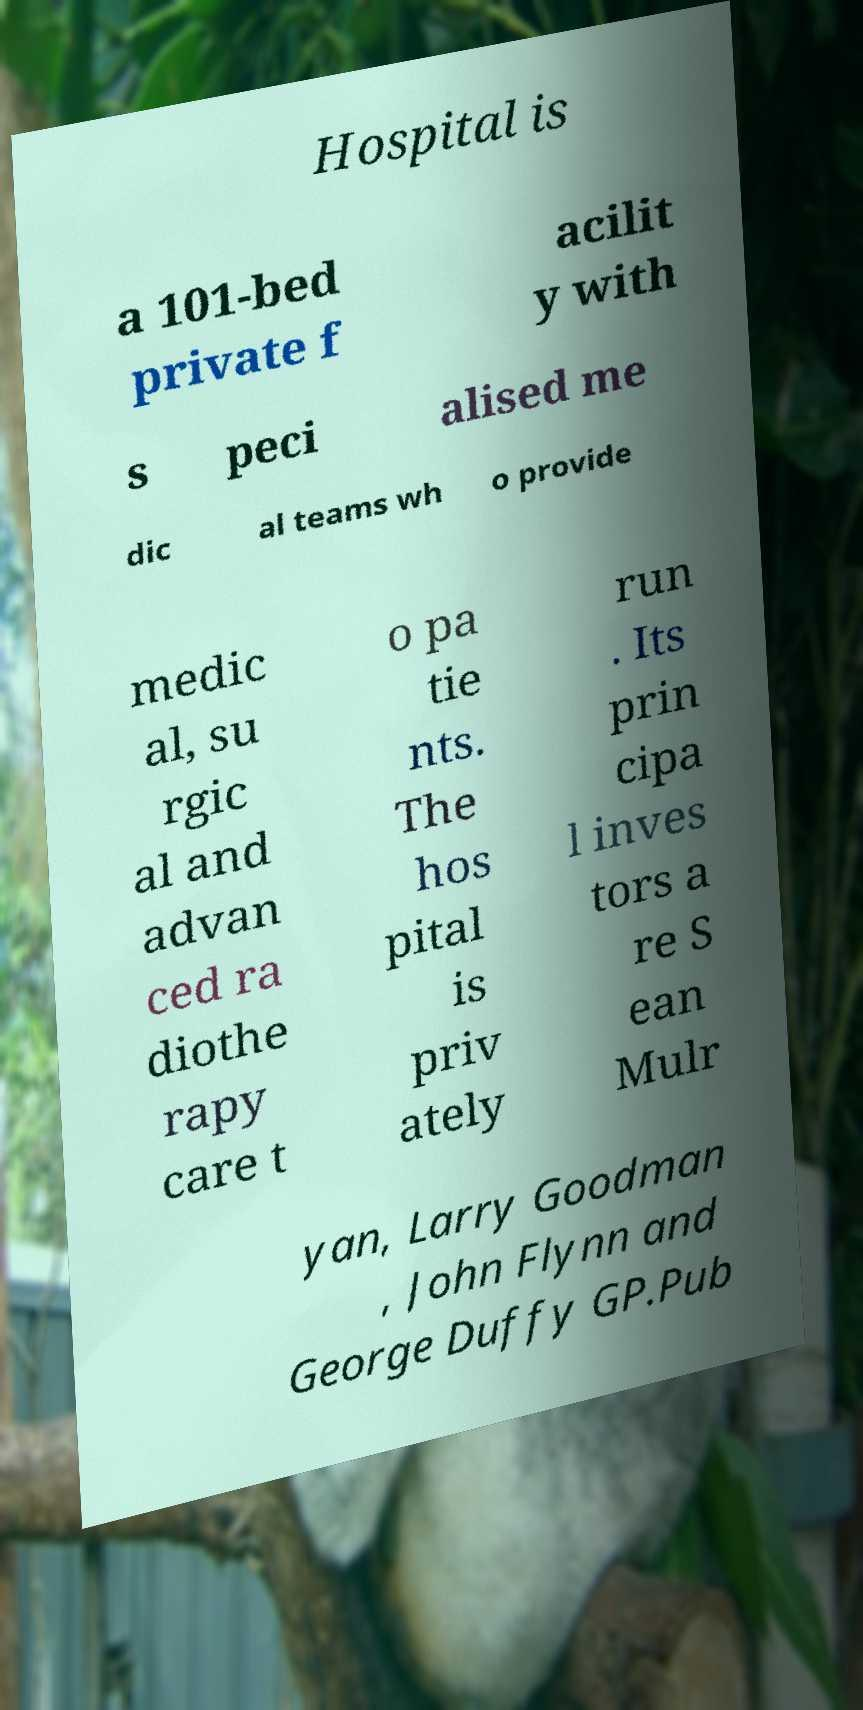Could you extract and type out the text from this image? Hospital is a 101-bed private f acilit y with s peci alised me dic al teams wh o provide medic al, su rgic al and advan ced ra diothe rapy care t o pa tie nts. The hos pital is priv ately run . Its prin cipa l inves tors a re S ean Mulr yan, Larry Goodman , John Flynn and George Duffy GP.Pub 